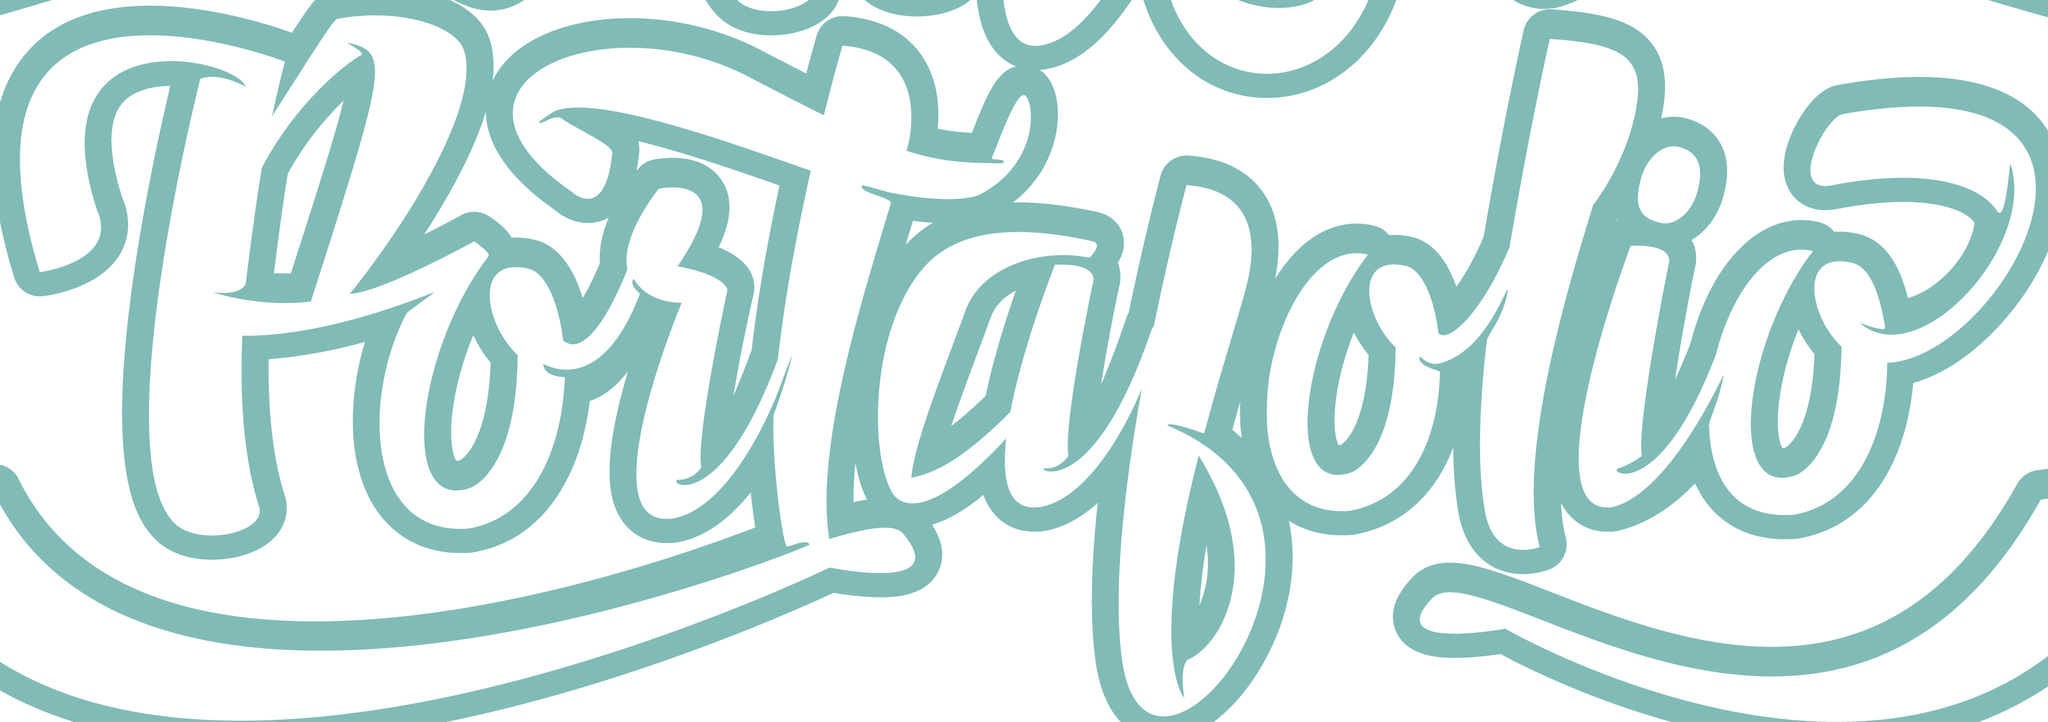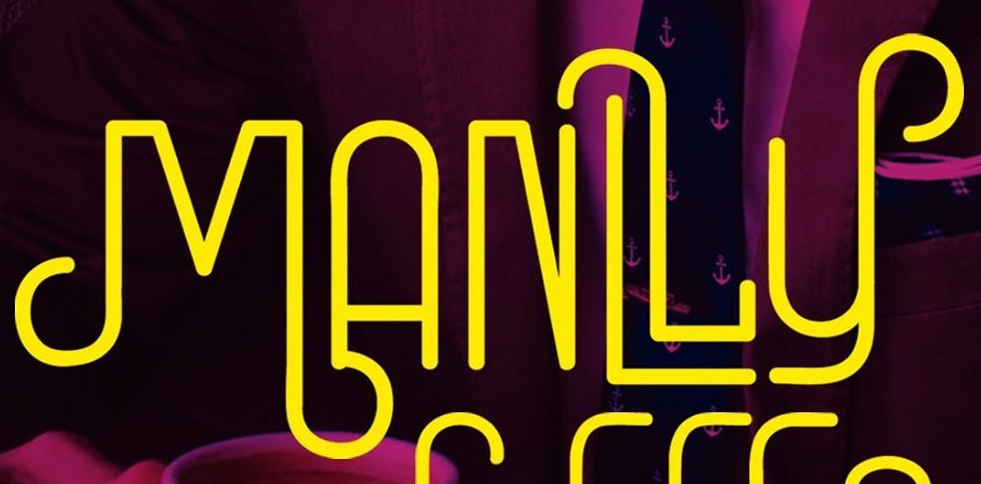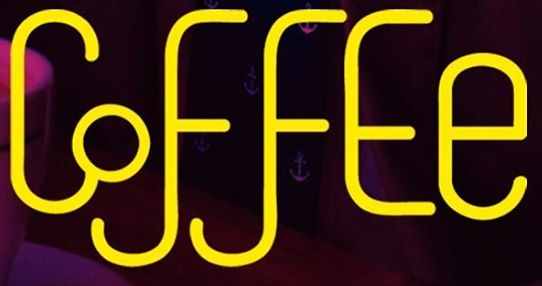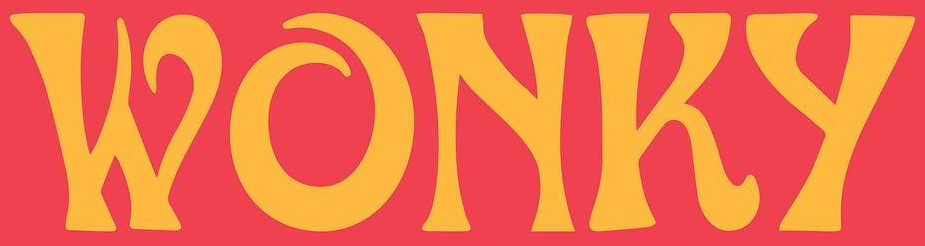What text appears in these images from left to right, separated by a semicolon? portalolio; MANLLy; CoffEe; WONKy 